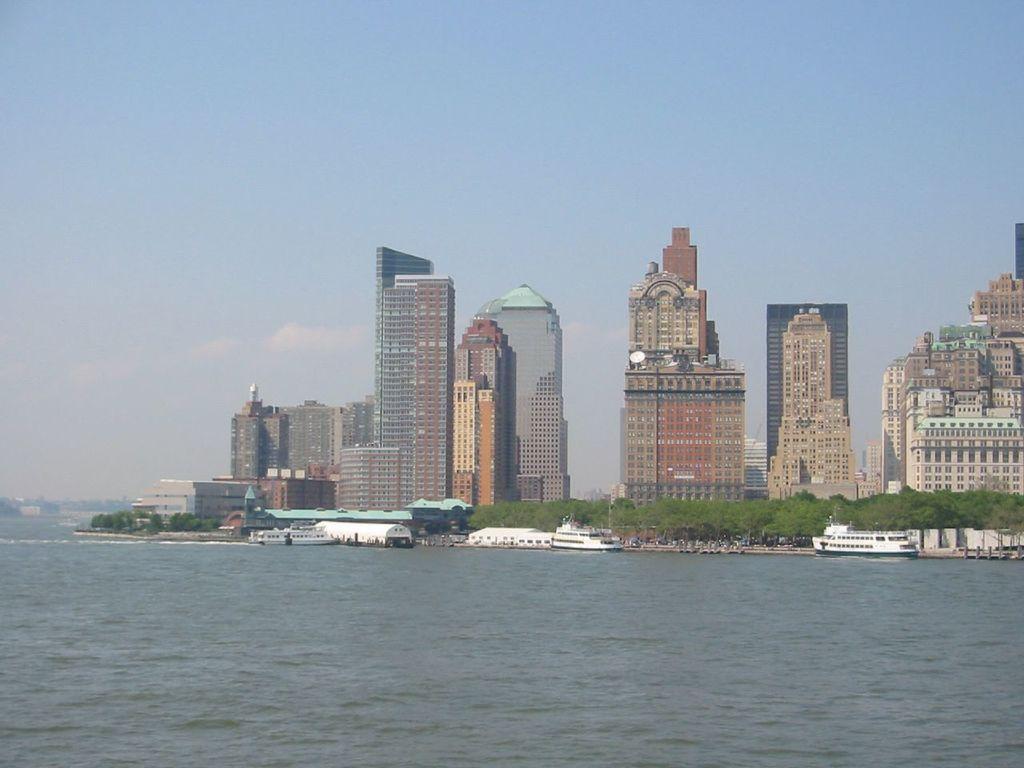Please provide a concise description of this image. In the center of the image there are buildings. There are boats. At the bottom of the image there is water. There are trees. 